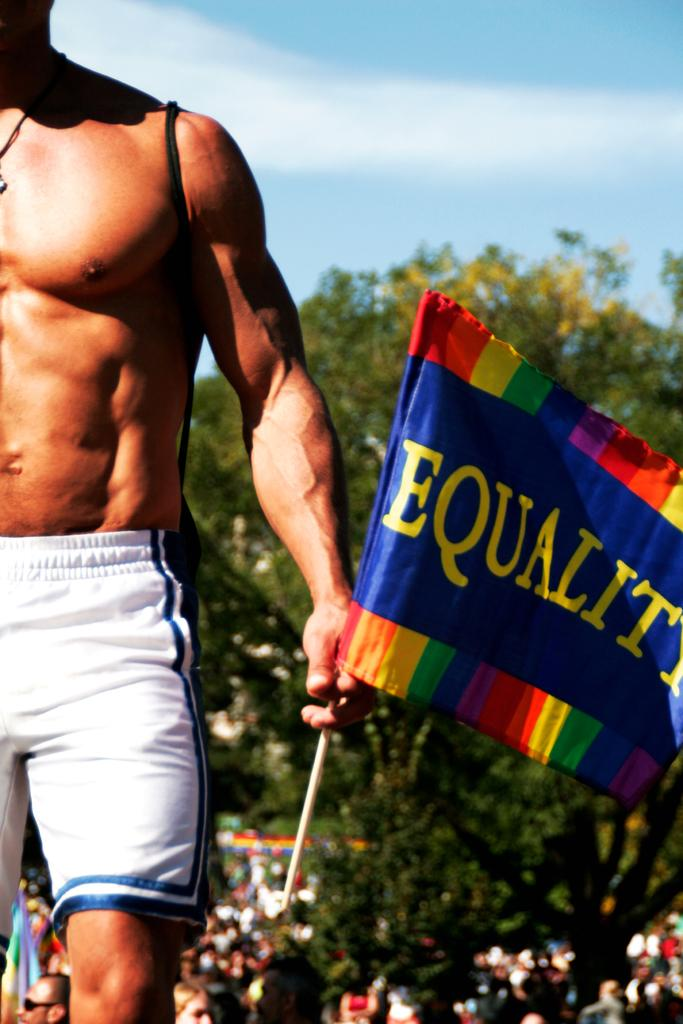What is the main subject of the image? There is a person in the image. Can you describe the person's clothing? The person is wearing a white and blue colored short. What is the person doing in the image? The person is standing and holding a flag in his hand. What can be seen in the background of the image? There are people, trees, and the sky visible in the background of the image. What type of alarm is going off in the image? There is no alarm present in the image. What holiday is being celebrated in the image? The image does not indicate any specific holiday being celebrated. 